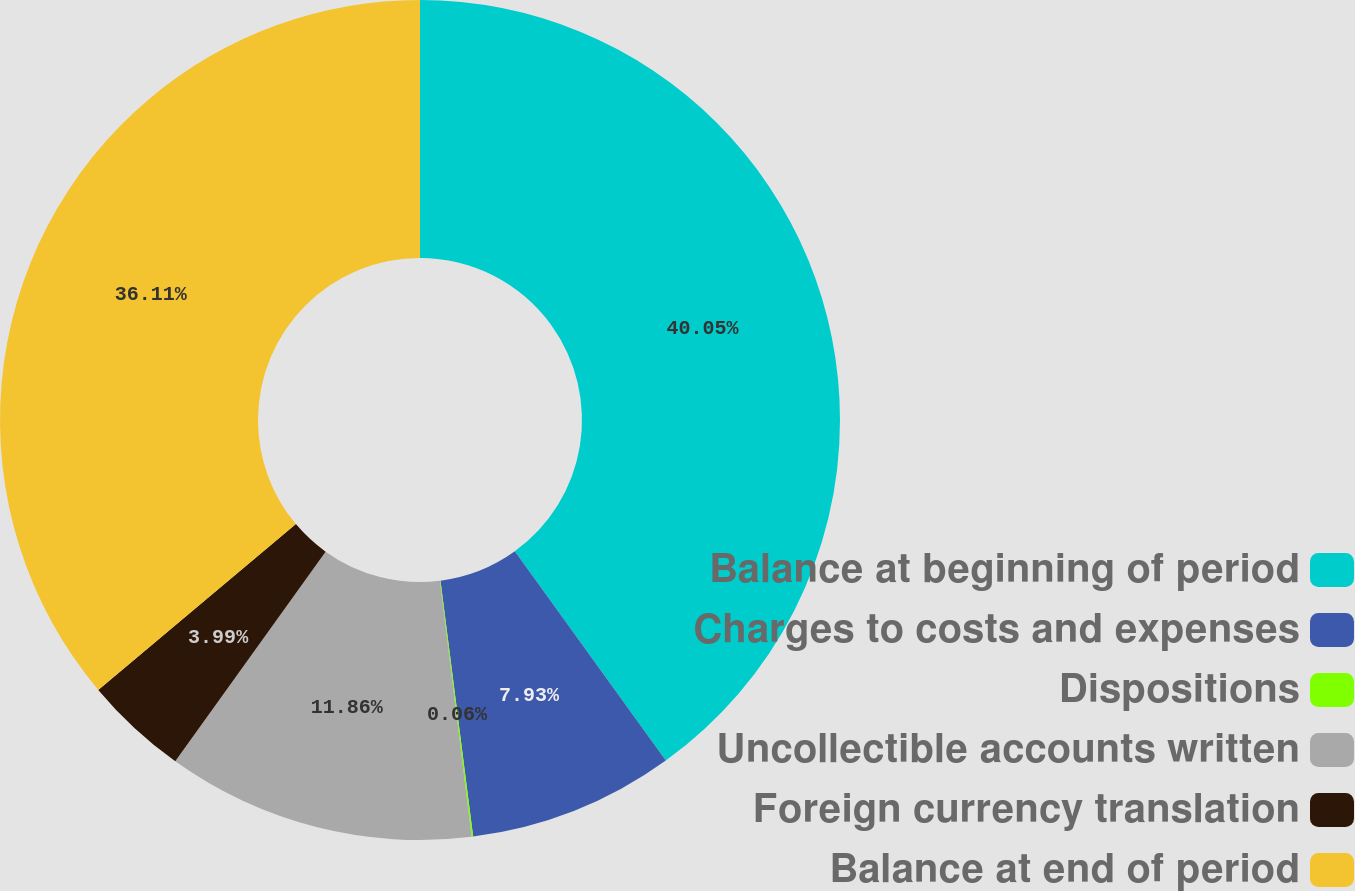Convert chart. <chart><loc_0><loc_0><loc_500><loc_500><pie_chart><fcel>Balance at beginning of period<fcel>Charges to costs and expenses<fcel>Dispositions<fcel>Uncollectible accounts written<fcel>Foreign currency translation<fcel>Balance at end of period<nl><fcel>40.05%<fcel>7.93%<fcel>0.06%<fcel>11.86%<fcel>3.99%<fcel>36.11%<nl></chart> 